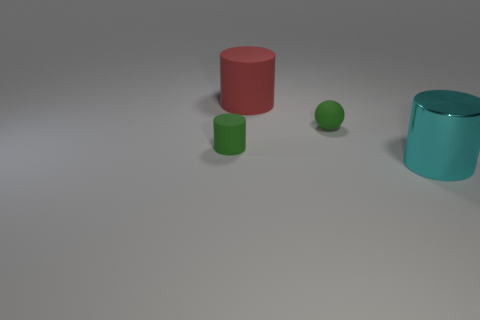Subtract 1 cylinders. How many cylinders are left? 2 Add 3 small green things. How many objects exist? 7 Subtract all balls. How many objects are left? 3 Subtract all big rubber objects. Subtract all tiny red matte cubes. How many objects are left? 3 Add 4 tiny green things. How many tiny green things are left? 6 Add 2 large blue cylinders. How many large blue cylinders exist? 2 Subtract 0 blue balls. How many objects are left? 4 